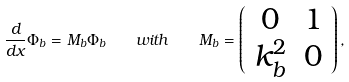Convert formula to latex. <formula><loc_0><loc_0><loc_500><loc_500>\frac { d } { d x } \Phi _ { b } = M _ { b } \Phi _ { b } \quad w i t h \quad M _ { b } = \left ( \begin{array} { c c c } 0 & 1 \\ k _ { b } ^ { 2 } & 0 \end{array} \right ) ,</formula> 